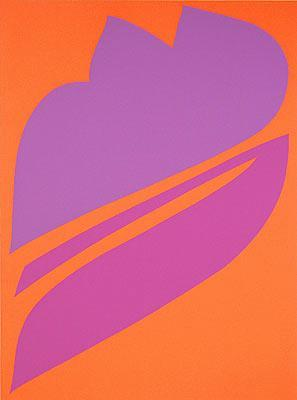How would this artwork influence the design of an indoor space? This artwork, when placed in an indoor setting, could significantly influence the space’s overall aesthetic. The vibrant orange and purple colors would bring a sense of warmth and energy, making it a perfect centerpiece for a modern living room or office. Its bold design can inspire the choice of complementary furniture and décor elements, such as neutral-colored sofas and minimalist accessories, to create a balanced and visually appealing environment. The presence of this abstract piece can also encourage a more creative and inspirational atmosphere, especially in workspaces or art studios. 